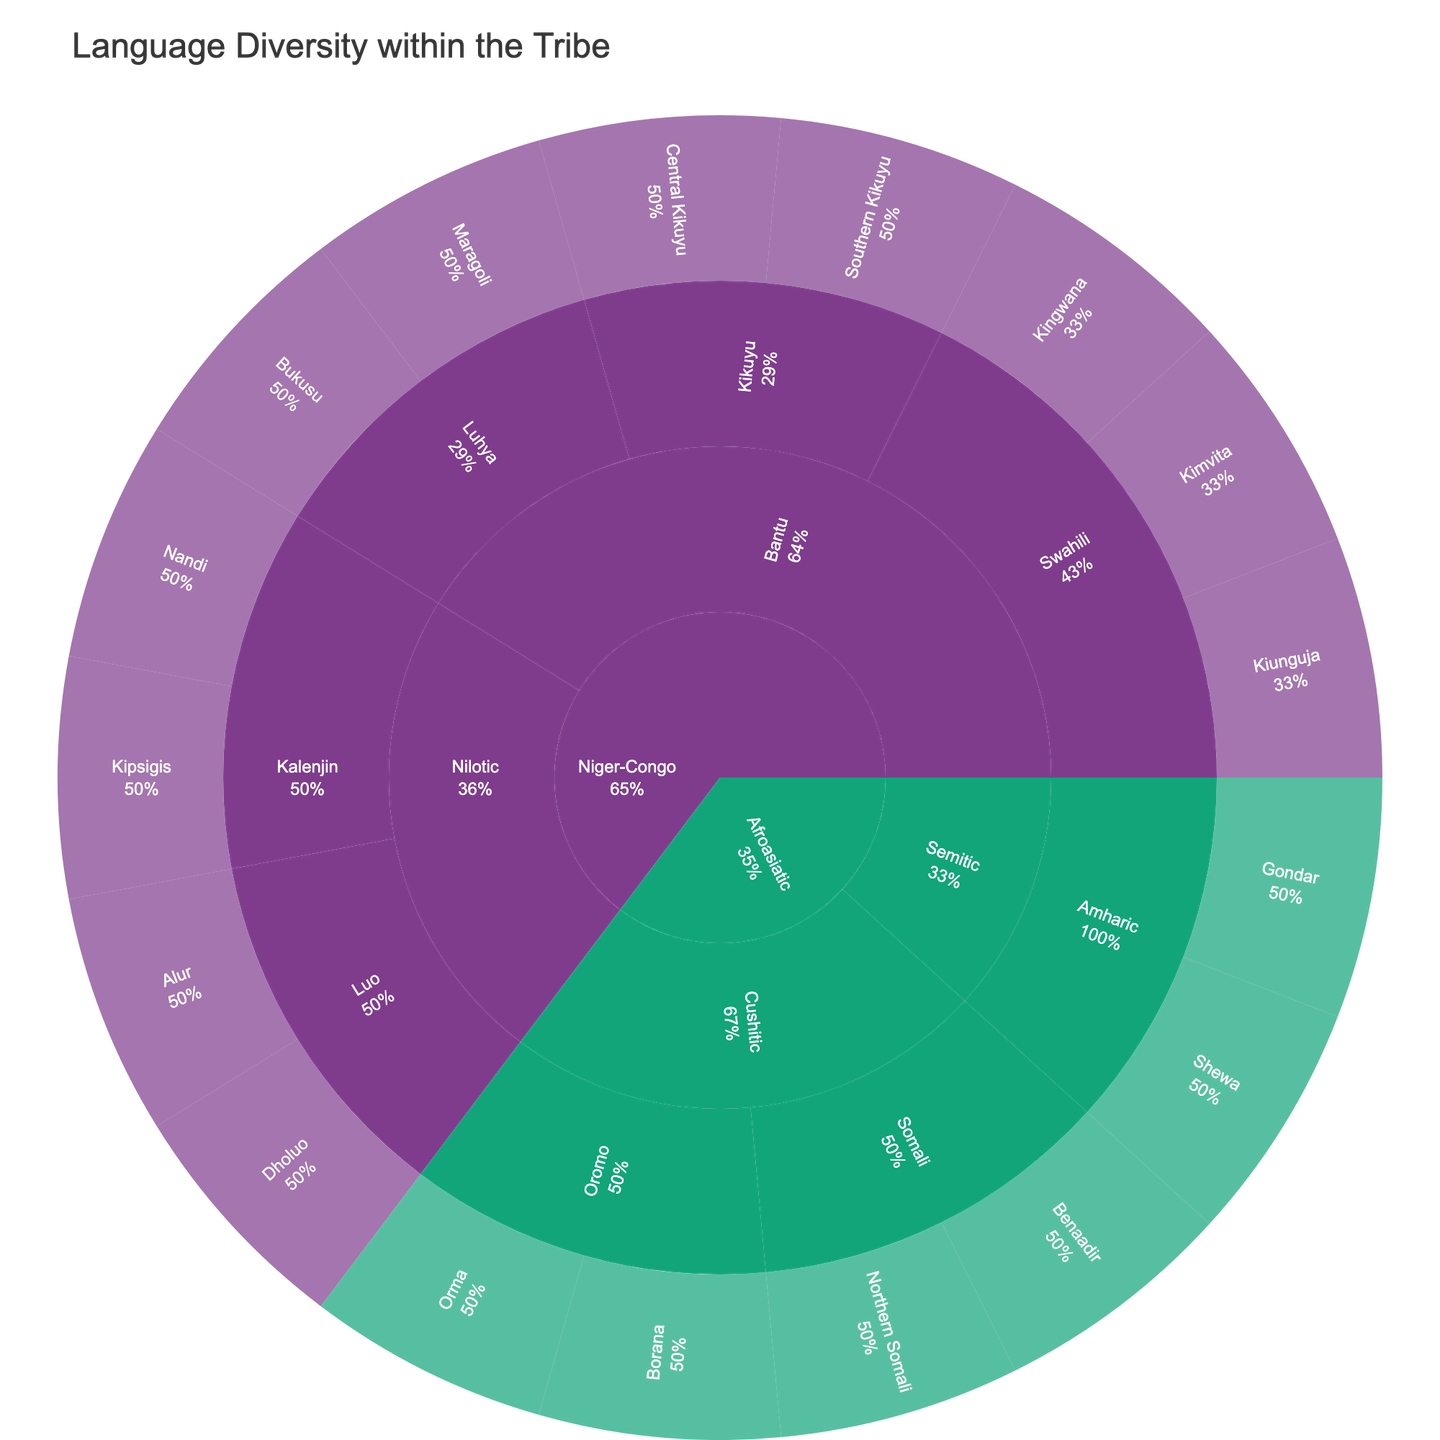What is the title of the sunburst plot? The title of the plot is typically displayed prominently at the top of the chart. In this case, the title mentioned in the code is "Language Diversity within the Tribe".
Answer: Language Diversity within the Tribe How many dialects of Swahili are represented in the plot? Look for the "Swahili" section within the "Bantu" group of the "Niger-Congo" language family. Count the number of dialects listed under Swahili.
Answer: 3 Which language family has the highest number of dialects depicted in the plot? Sum up the number of dialects for each language family by examining each section of the plot. The "Niger-Congo" family has the highest number of dialects.
Answer: Niger-Congo Between the Bantu and Nilotic language groups within the Niger-Congo family, which has more dialects represented? Navigate through the "Niger-Congo" language family, then compare the total number of dialects under "Bantu" and "Nilotic". Count them respectively to identify which has more.
Answer: Bantu Which dialect of Somali is listed first in the plot? Under the "Afroasiatic" family, go to the "Cushitic" group and then find "Somali". The first dialect listed should be under Somali.
Answer: Northern Somali How many language families are represented in the plot? The language families are at the first level of the plot. Count all distinct sections at this level to find the total number of language families.
Answer: 2 How many dialects are there in total under the "Cushitic" language group? Locate the "Cushitic" group within the "Afroasiatic" family, then count all the dialects listed under it.
Answer: 4 Which language under the "Kikuyu" language group has the lowest number of dialects? Look under the "Niger-Congo" family for the "Kikuyu" group. Observe and compare the number of dialects listed under each language within this group.
Answer: Central Kikuyu and Southern Kikuyu (both have 1 dialect) Is there an equal number of languages under "Somali" and "Oromo"? In the "Afroasiatic" family, compare the number of languages listed under the "Somali" group to those under the "Oromo" group.
Answer: Yes What percentage of the languages in the "Bantu" group are Swahili dialects? Identify the total number of languages in the "Bantu" group under the "Niger-Congo" family and calculate the percentage represented by the Swahili dialects. There are 7 dialects and 3 are Swahili, so the percentage is (3/7) * 100.
Answer: Approximately 42.9% 